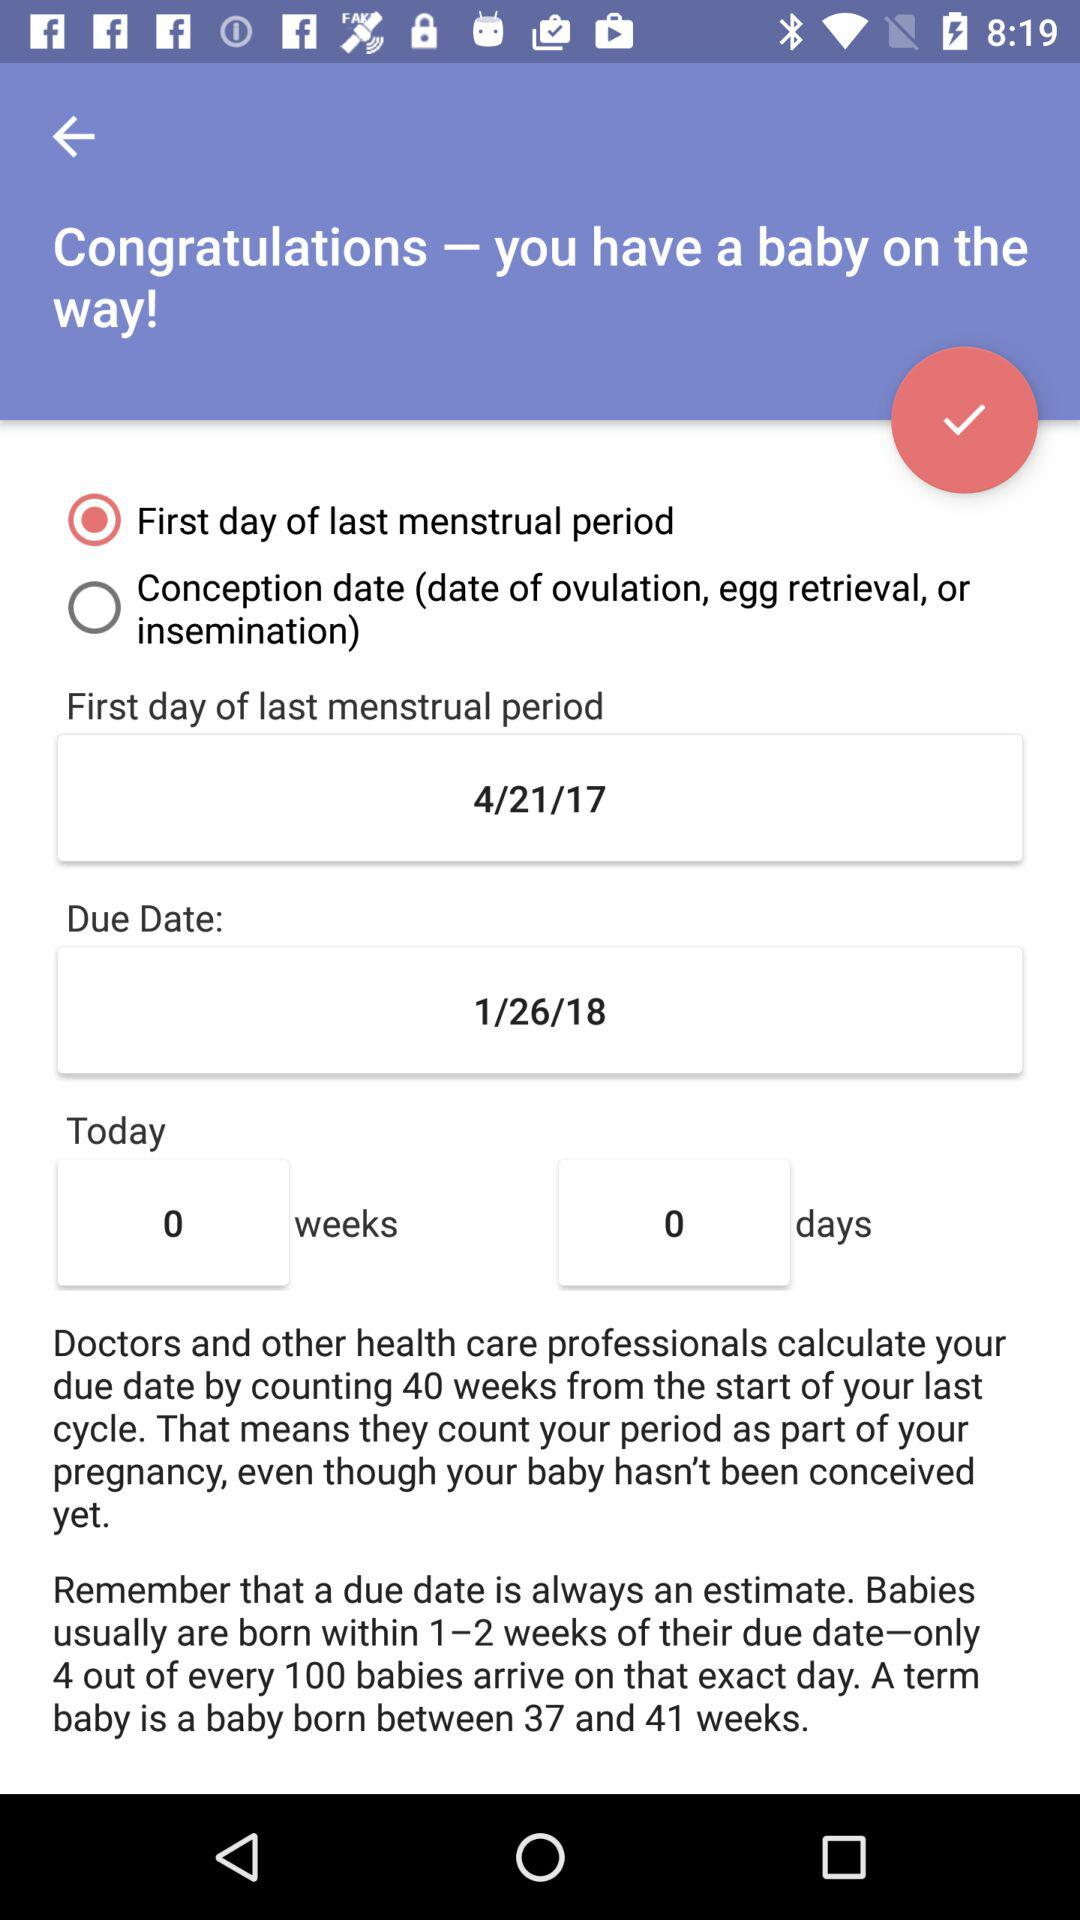What is the due date? The due date is 1/26/18. 